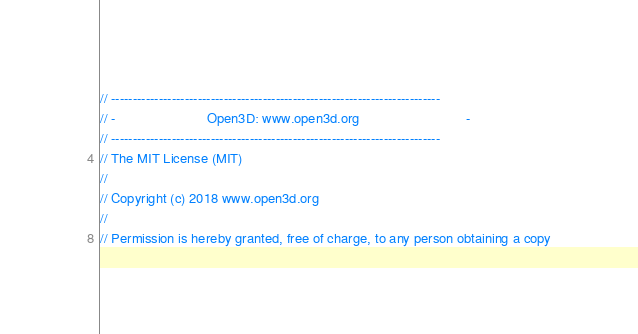<code> <loc_0><loc_0><loc_500><loc_500><_C++_>// ----------------------------------------------------------------------------
// -                        Open3D: www.open3d.org                            -
// ----------------------------------------------------------------------------
// The MIT License (MIT)
//
// Copyright (c) 2018 www.open3d.org
//
// Permission is hereby granted, free of charge, to any person obtaining a copy</code> 